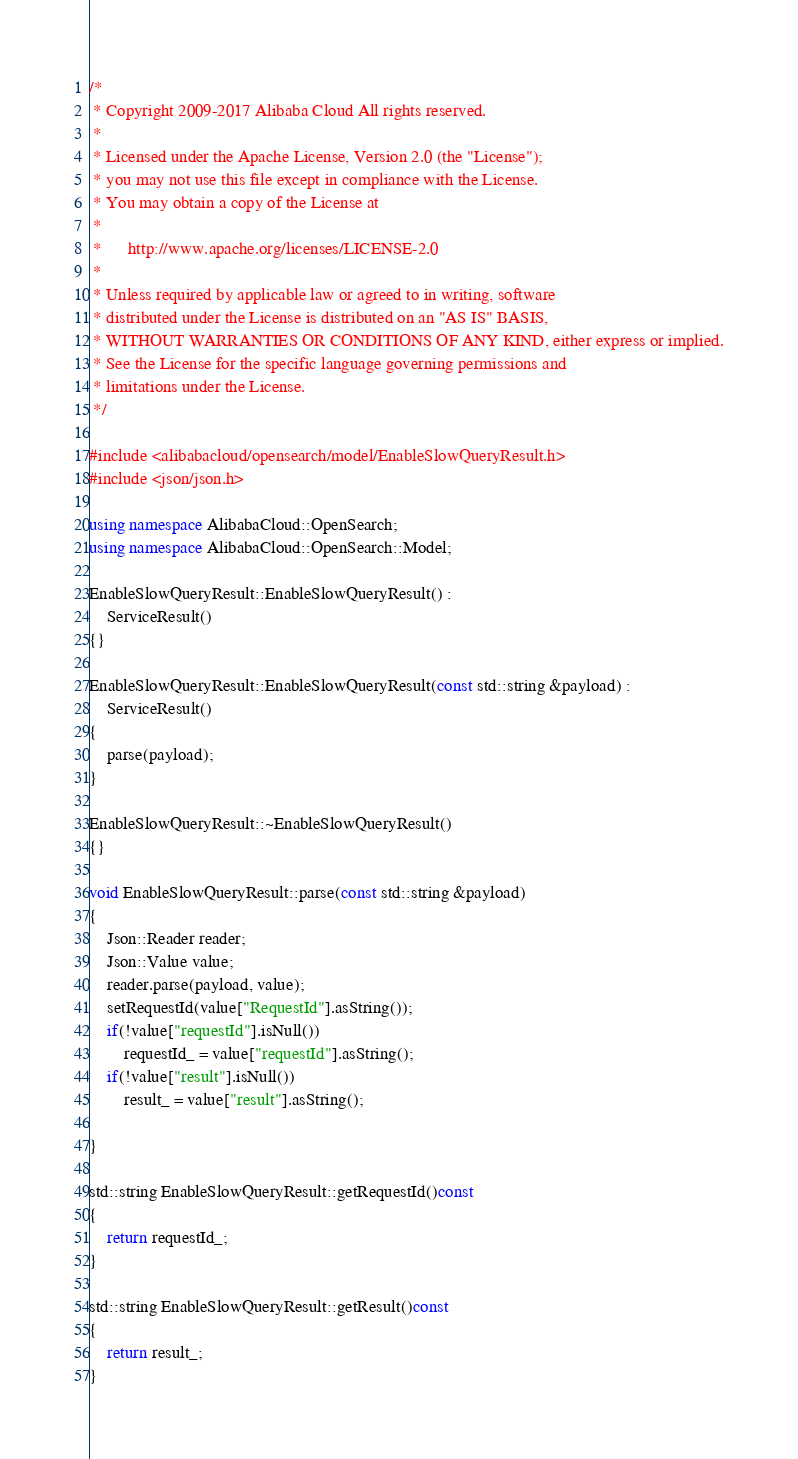Convert code to text. <code><loc_0><loc_0><loc_500><loc_500><_C++_>/*
 * Copyright 2009-2017 Alibaba Cloud All rights reserved.
 * 
 * Licensed under the Apache License, Version 2.0 (the "License");
 * you may not use this file except in compliance with the License.
 * You may obtain a copy of the License at
 * 
 *      http://www.apache.org/licenses/LICENSE-2.0
 * 
 * Unless required by applicable law or agreed to in writing, software
 * distributed under the License is distributed on an "AS IS" BASIS,
 * WITHOUT WARRANTIES OR CONDITIONS OF ANY KIND, either express or implied.
 * See the License for the specific language governing permissions and
 * limitations under the License.
 */

#include <alibabacloud/opensearch/model/EnableSlowQueryResult.h>
#include <json/json.h>

using namespace AlibabaCloud::OpenSearch;
using namespace AlibabaCloud::OpenSearch::Model;

EnableSlowQueryResult::EnableSlowQueryResult() :
	ServiceResult()
{}

EnableSlowQueryResult::EnableSlowQueryResult(const std::string &payload) :
	ServiceResult()
{
	parse(payload);
}

EnableSlowQueryResult::~EnableSlowQueryResult()
{}

void EnableSlowQueryResult::parse(const std::string &payload)
{
	Json::Reader reader;
	Json::Value value;
	reader.parse(payload, value);
	setRequestId(value["RequestId"].asString());
	if(!value["requestId"].isNull())
		requestId_ = value["requestId"].asString();
	if(!value["result"].isNull())
		result_ = value["result"].asString();

}

std::string EnableSlowQueryResult::getRequestId()const
{
	return requestId_;
}

std::string EnableSlowQueryResult::getResult()const
{
	return result_;
}

</code> 